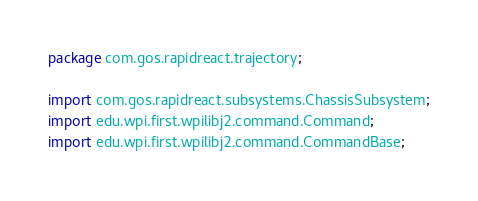<code> <loc_0><loc_0><loc_500><loc_500><_Java_>package com.gos.rapidreact.trajectory;

import com.gos.rapidreact.subsystems.ChassisSubsystem;
import edu.wpi.first.wpilibj2.command.Command;
import edu.wpi.first.wpilibj2.command.CommandBase;
</code> 